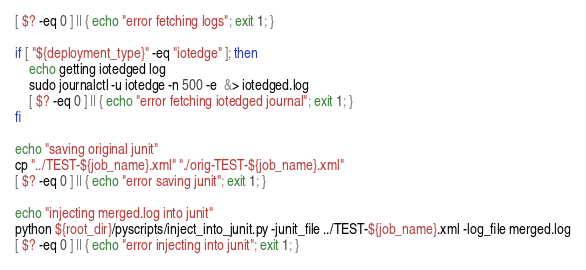Convert code to text. <code><loc_0><loc_0><loc_500><loc_500><_Bash_>[ $? -eq 0 ] || { echo "error fetching logs"; exit 1; }

if [ "${deployment_type}" -eq "iotedge" ]; then
    echo getting iotedged log
    sudo journalctl -u iotedge -n 500 -e  &> iotedged.log
    [ $? -eq 0 ] || { echo "error fetching iotedged journal"; exit 1; }
fi

echo "saving original junit"
cp "../TEST-${job_name}.xml" "./orig-TEST-${job_name}.xml"
[ $? -eq 0 ] || { echo "error saving junit"; exit 1; }

echo "injecting merged.log into junit"
python ${root_dir}/pyscripts/inject_into_junit.py -junit_file ../TEST-${job_name}.xml -log_file merged.log
[ $? -eq 0 ] || { echo "error injecting into junit"; exit 1; }

</code> 